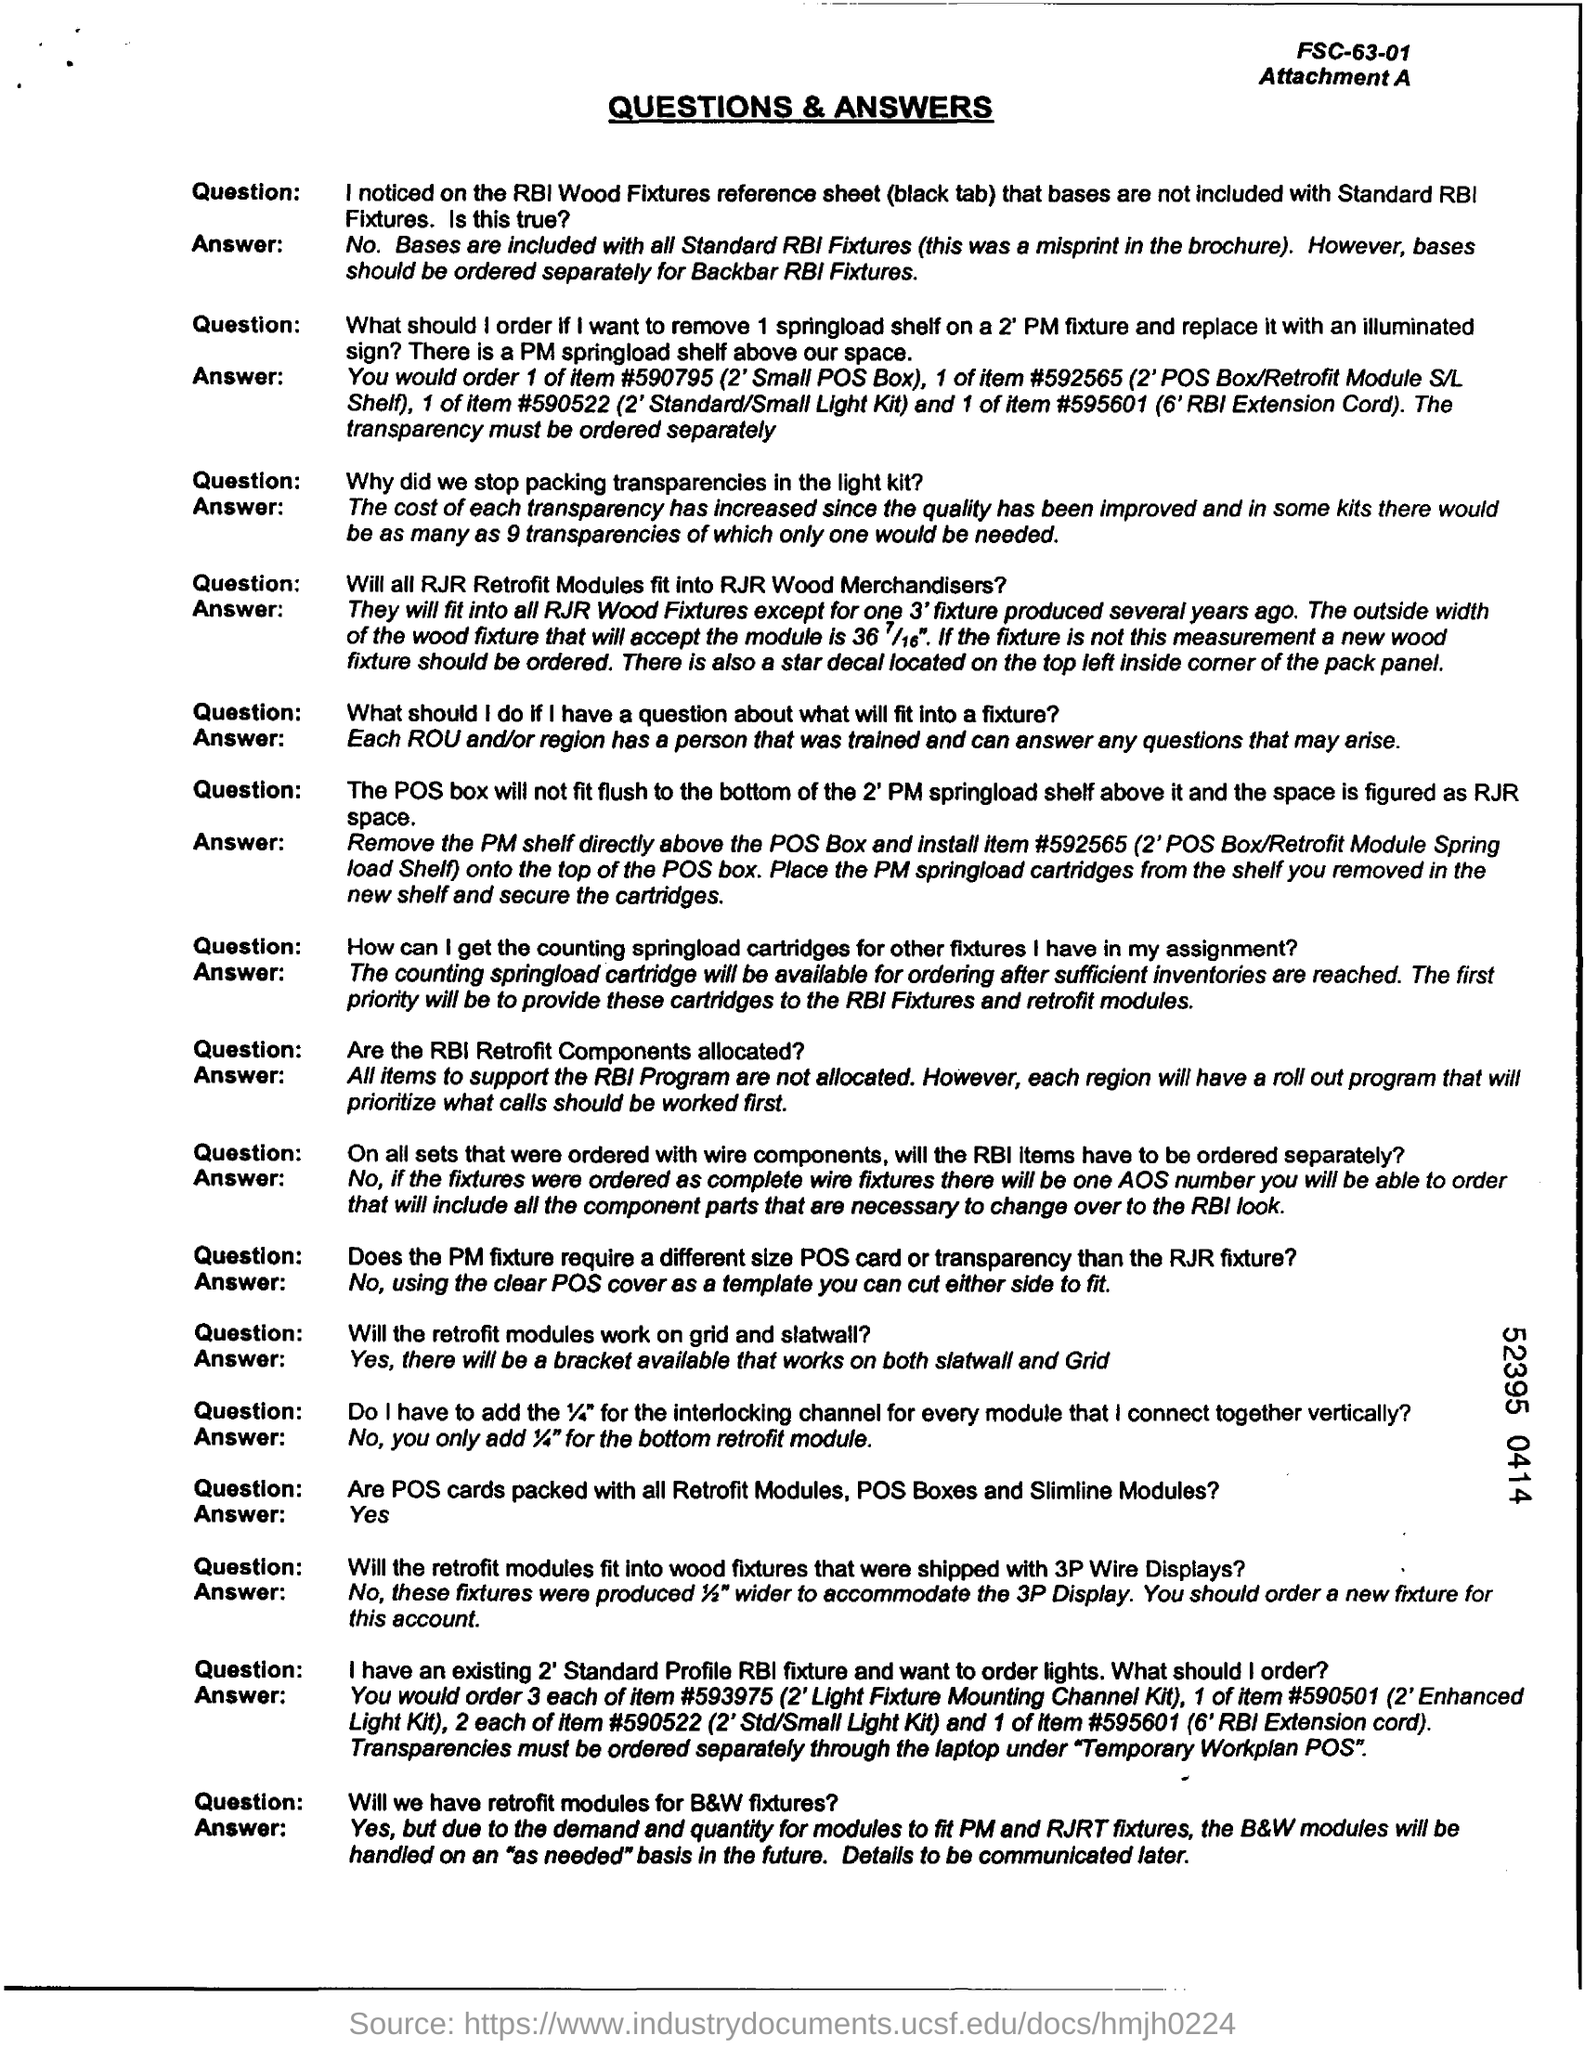What is the title of the document?
Your answer should be compact. Questions & Answers. 